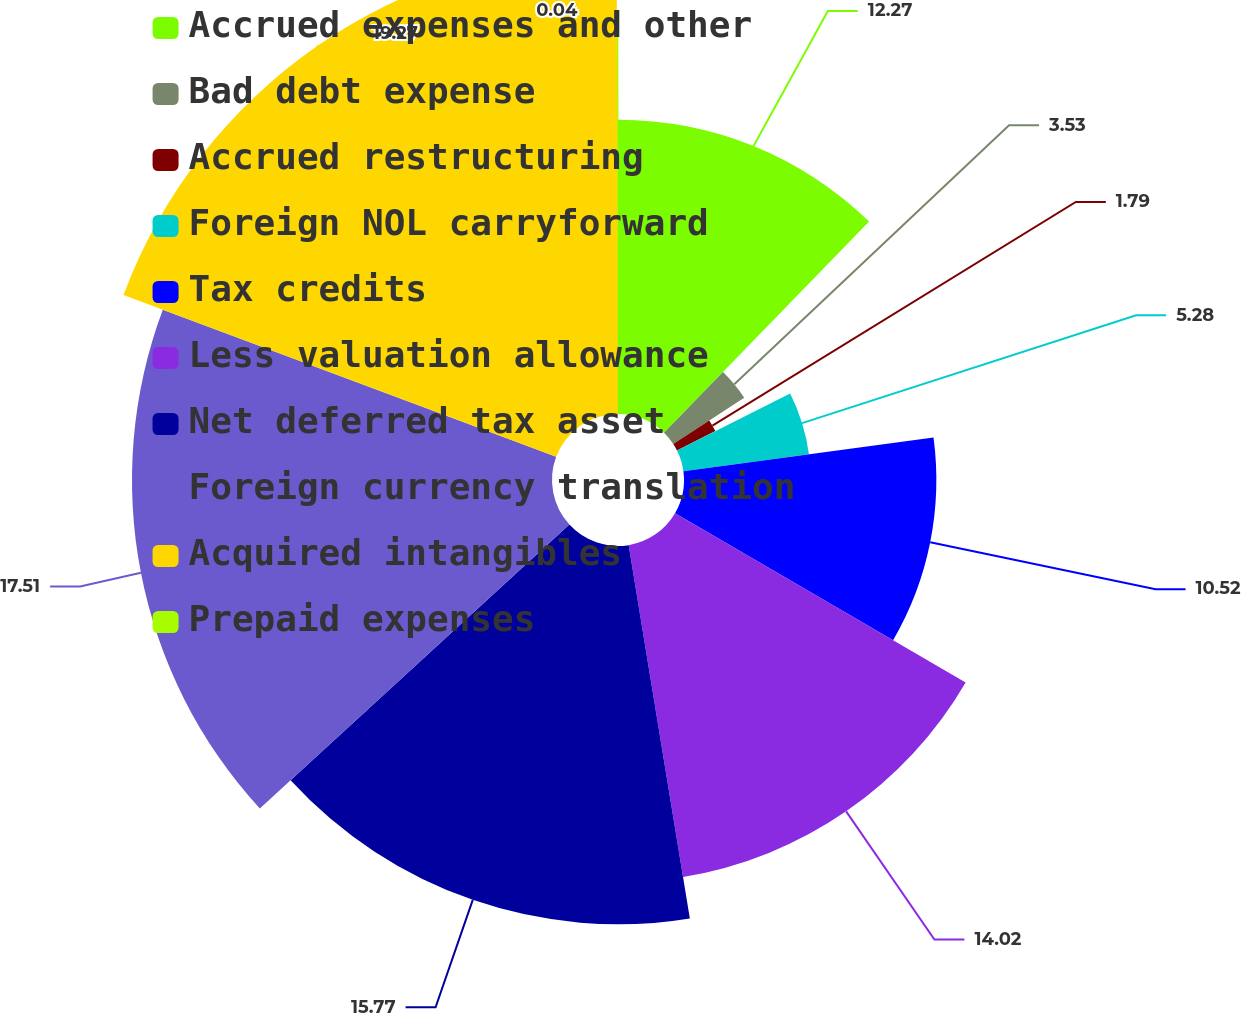Convert chart to OTSL. <chart><loc_0><loc_0><loc_500><loc_500><pie_chart><fcel>Accrued expenses and other<fcel>Bad debt expense<fcel>Accrued restructuring<fcel>Foreign NOL carryforward<fcel>Tax credits<fcel>Less valuation allowance<fcel>Net deferred tax asset<fcel>Foreign currency translation<fcel>Acquired intangibles<fcel>Prepaid expenses<nl><fcel>12.27%<fcel>3.53%<fcel>1.79%<fcel>5.28%<fcel>10.52%<fcel>14.02%<fcel>15.77%<fcel>17.51%<fcel>19.26%<fcel>0.04%<nl></chart> 